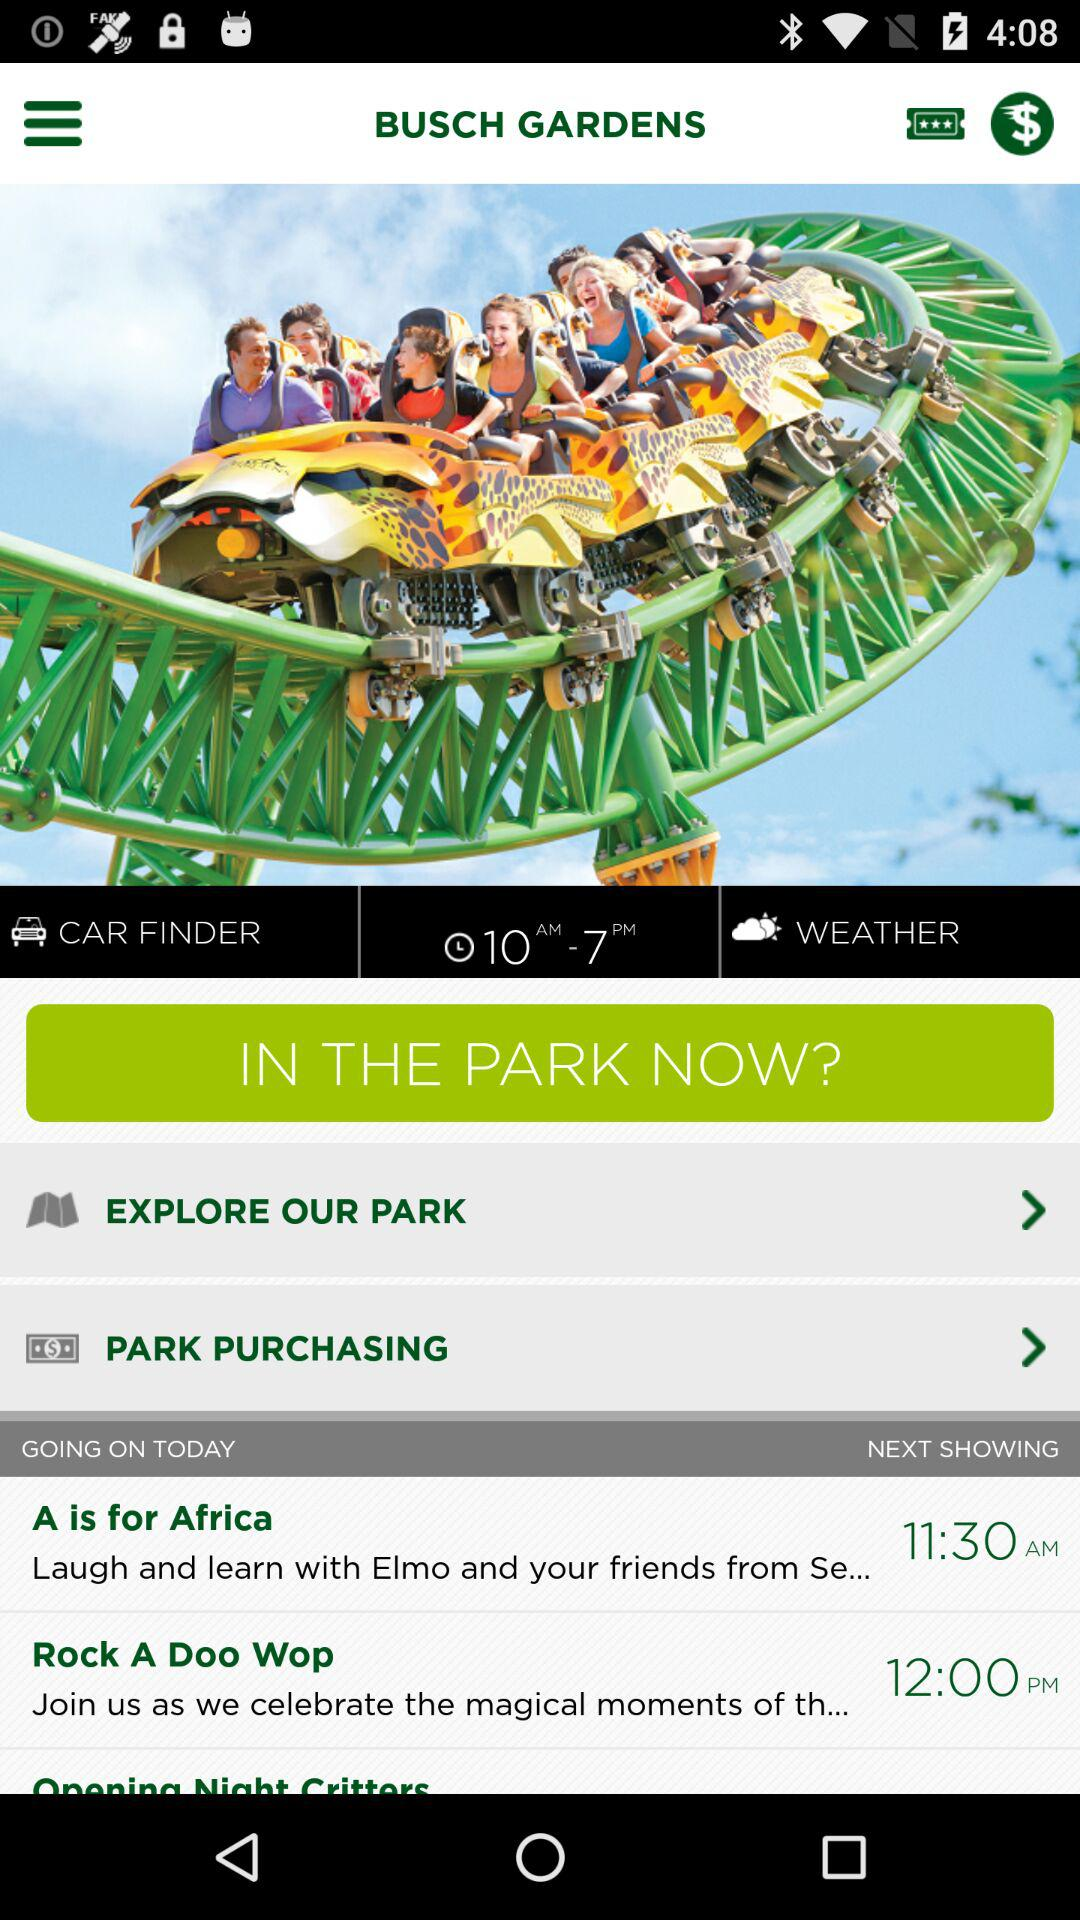What is the time for Rock A Doo Wop? The time for Rock A Doo Wop is 12:00 PM. 